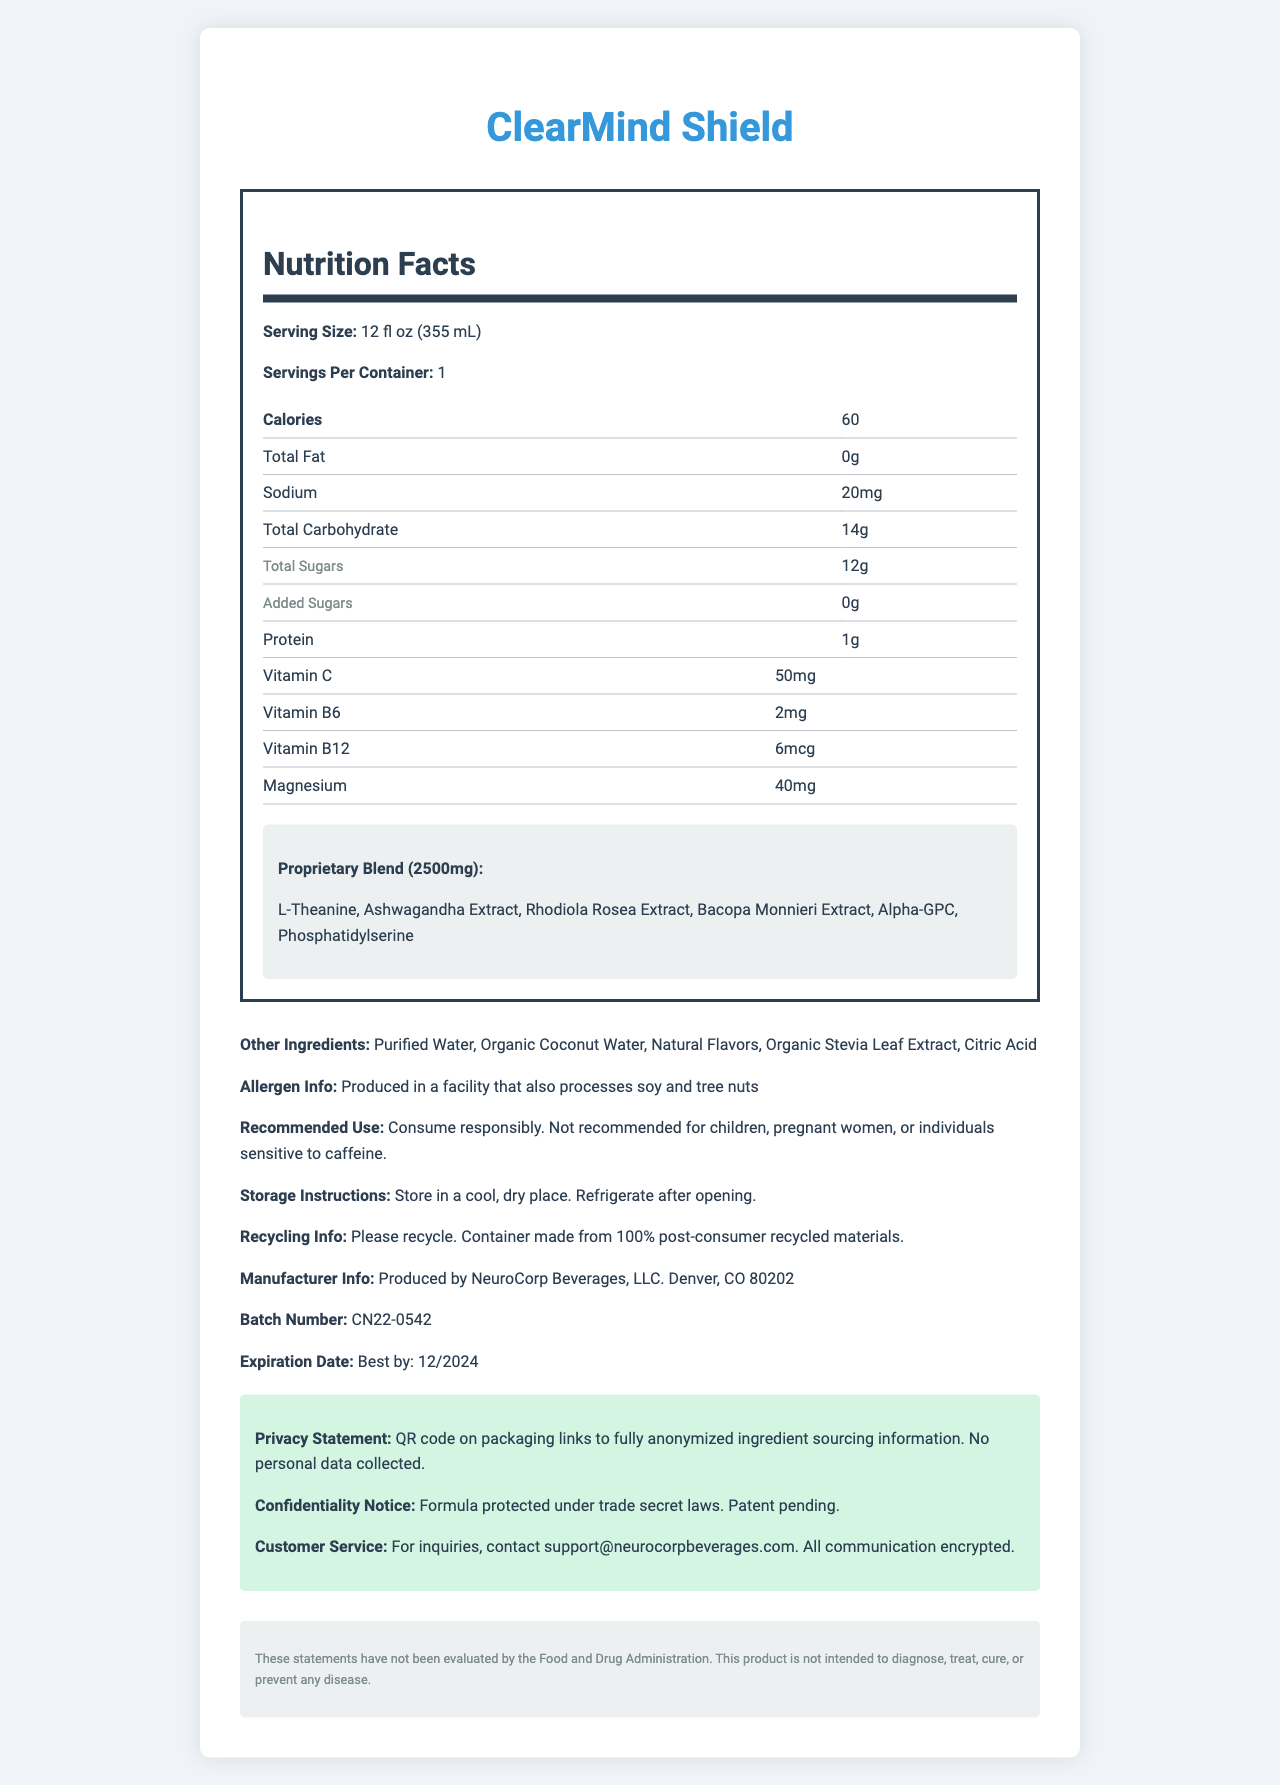what is the serving size of ClearMind Shield? The serving size is listed directly under the "Nutrition Facts" section in the document alongside other nutritional information.
Answer: 12 fl oz (355 mL) how many calories are in a serving of ClearMind Shield? The calorie content per serving is clearly mentioned in the "Nutrition Facts" section.
Answer: 60 calories which vitamin is present in the highest amount in ClearMind Shield? Vitamin C content is 50mg per serving, which is presented with other vitamins in the "Nutrition Facts" section.
Answer: Vitamin C what is the sodium content in ClearMind Shield? The sodium content is specified as 20mg and is visible in the "Nutrition Facts" section.
Answer: 20mg name three ingredients in the proprietary blend. These ingredients are listed as part of the "Proprietary Blend" section in the document.
Answer: L-Theanine, Ashwagandha Extract, Rhodiola Rosea Extract which of the following is not an ingredient in ClearMind Shield? A. Organic Stevia Leaf Extract B. Citric Acid C. High Fructose Corn Syrup High Fructose Corn Syrup is not listed under the "Other Ingredients" section.
Answer: C how many grams of protein does ClearMind Shield contain? The amount of protein is listed as 1g in the "Nutrition Facts" section.
Answer: 1g what is the expiration date of ClearMind Shield? The expiration date is clearly stated in the document under "Expiration Date".
Answer: Best by: 12/2024 is ClearMind Shield recommended for pregnant women? The document states that the product is not recommended for pregnant women under "Recommended Use".
Answer: No is any personal data collected via the QR code on the packaging? The privacy statement explicitly mentions that no personal data is collected via the QR code on the packaging.
Answer: No which company produces ClearMind Shield? A. ClearCorp LLC B. NeuroCorp Beverages, LLC C. VitaWell Inc The "Manufacturer Info" indicates that the product is produced by NeuroCorp Beverages, LLC.
Answer: B which vitamin is present in the least amount in ClearMind Shield? Vitamin B12 content is 6mcg, which is lower than the amounts of Vitamin C, Vitamin B6, and Magnesium listed.
Answer: Vitamin B12 what is the proprietary blend amount in ClearMind Shield? The proprietary blend amount is listed as 2500mg in the "Proprietary Blend" section.
Answer: 2500mg summarize the main features of ClearMind Shield. The document provides detailed nutritional information, highlights the proprietary blend, lists other ingredients, includes allergy information, and outlines manufacturer details along with privacy and warranty notices.
Answer: ClearMind Shield is an energy drink with 60 calories per serving, containing 0g total fat, 20mg sodium, 14g total carbohydrates, and 1g protein. It includes natural nootropics and stress-reducing compounds within a 2500mg proprietary blend, consisting of ingredients like L-Theanine and Ashwagandha Extract. It is produced by NeuroCorp Beverages, LLC and has privacy and confidentiality safeguards. what is the total amount of added sugars in ClearMind Shield? The "Nutrition Facts" section specifies that the drink contains 0 grams of added sugars.
Answer: 0g does ClearMind Shield contain any dairy ingredients? The document does not specify whether any ingredients are derived from dairy, only listing allergen information related to soy and tree nuts.
Answer: Cannot be determined where is the QR code mentioned in the privacy statement supposed to link to? The privacy statement notes that the QR code on the packaging links to fully anonymized ingredient sourcing information.
Answer: Fully anonymized ingredient sourcing information what is the legal disclaimer mentioned in the document? The legal disclaimer can be found towards the end of the document, providing required FDA disclaimer language.
Answer: These statements have not been evaluated by the Food and Drug Administration. This product is not intended to diagnose, treat, cure, or prevent any disease. 